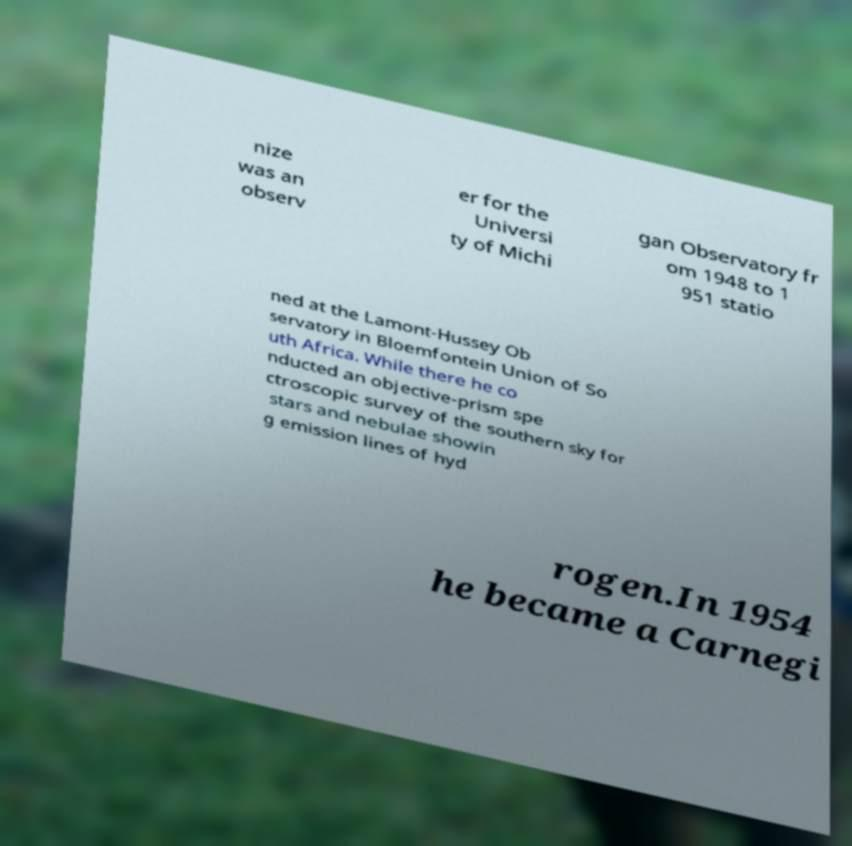Can you read and provide the text displayed in the image?This photo seems to have some interesting text. Can you extract and type it out for me? nize was an observ er for the Universi ty of Michi gan Observatory fr om 1948 to 1 951 statio ned at the Lamont-Hussey Ob servatory in Bloemfontein Union of So uth Africa. While there he co nducted an objective-prism spe ctroscopic survey of the southern sky for stars and nebulae showin g emission lines of hyd rogen.In 1954 he became a Carnegi 